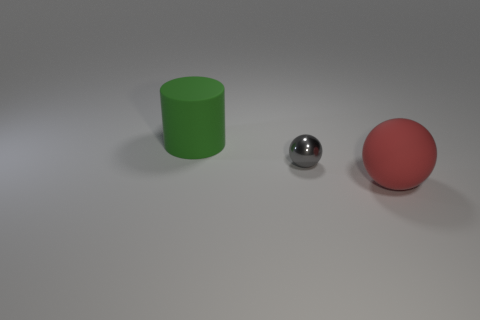What textures are represented in the objects within this image? The objects in the image exhibit three different textures. The green cylinder has a smooth and opaque texture, the silver sphere has a reflective and shiny texture, and the red ball has a diffuse, matte texture without any reflection. 